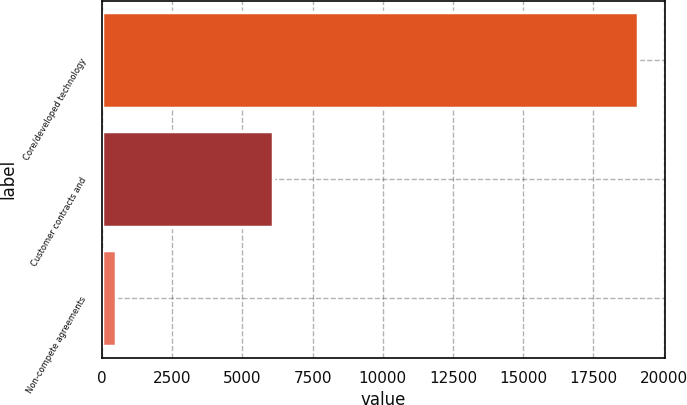<chart> <loc_0><loc_0><loc_500><loc_500><bar_chart><fcel>Core/developed technology<fcel>Customer contracts and<fcel>Non-compete agreements<nl><fcel>19100<fcel>6100<fcel>500<nl></chart> 